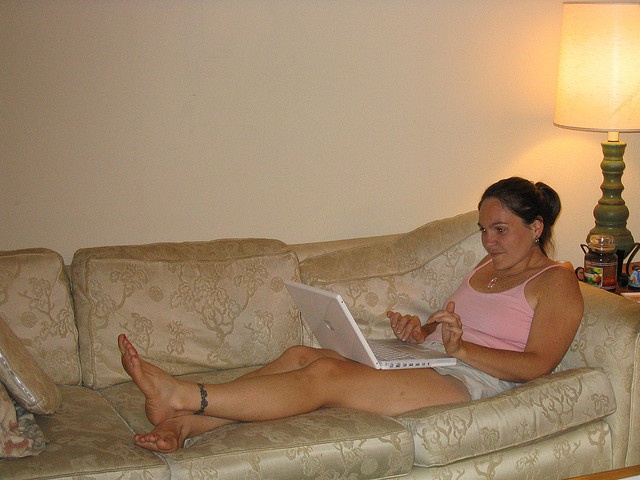Describe the objects in this image and their specific colors. I can see couch in gray tones, people in gray, brown, and darkgray tones, laptop in gray and darkgray tones, and bottle in gray, maroon, black, and olive tones in this image. 